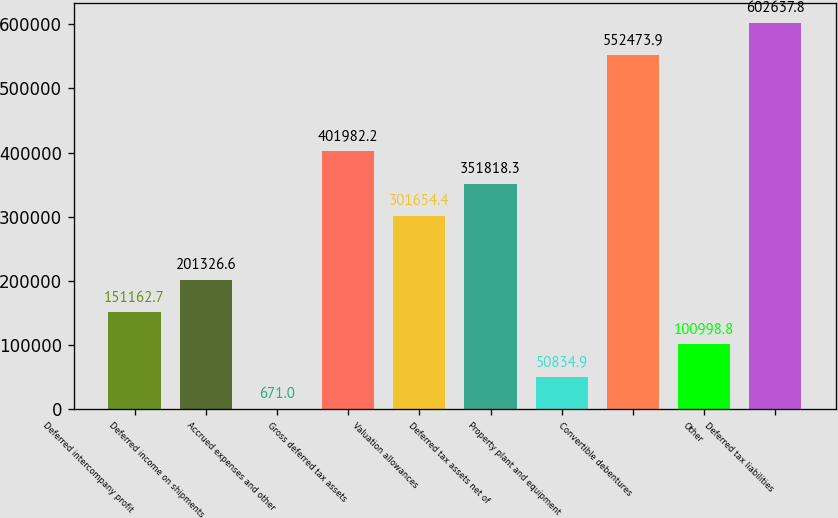<chart> <loc_0><loc_0><loc_500><loc_500><bar_chart><fcel>Deferred intercompany profit<fcel>Deferred income on shipments<fcel>Accrued expenses and other<fcel>Gross deferred tax assets<fcel>Valuation allowances<fcel>Deferred tax assets net of<fcel>Property plant and equipment<fcel>Convertible debentures<fcel>Other<fcel>Deferred tax liabilities<nl><fcel>151163<fcel>201327<fcel>671<fcel>401982<fcel>301654<fcel>351818<fcel>50834.9<fcel>552474<fcel>100999<fcel>602638<nl></chart> 